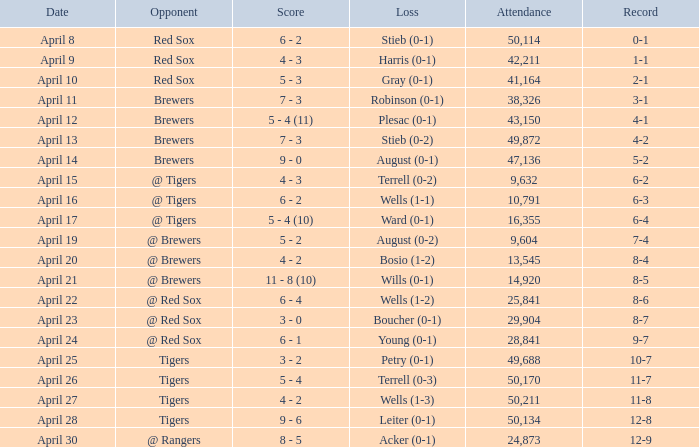Which opponent has a loss of wells (1-3)? Tigers. 